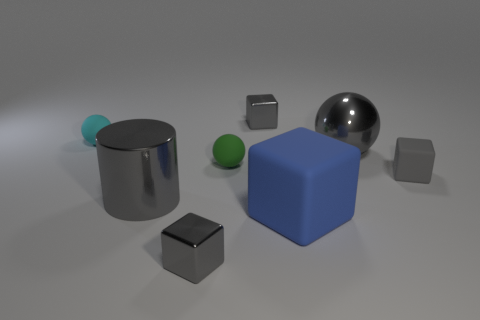How many gray blocks must be subtracted to get 1 gray blocks? 2 Subtract all gray balls. How many balls are left? 2 Add 1 tiny blue matte things. How many objects exist? 9 Subtract 1 blocks. How many blocks are left? 3 Subtract all purple spheres. How many brown cubes are left? 0 Subtract all gray cubes. Subtract all large gray things. How many objects are left? 3 Add 1 gray metal cubes. How many gray metal cubes are left? 3 Add 4 tiny purple matte cylinders. How many tiny purple matte cylinders exist? 4 Subtract all green balls. How many balls are left? 2 Subtract 0 blue cylinders. How many objects are left? 8 